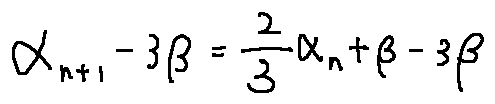<formula> <loc_0><loc_0><loc_500><loc_500>\alpha _ { n + 1 } - 3 \beta = \frac { 2 } { 3 } \alpha _ { n } + \beta - 3 \beta</formula> 